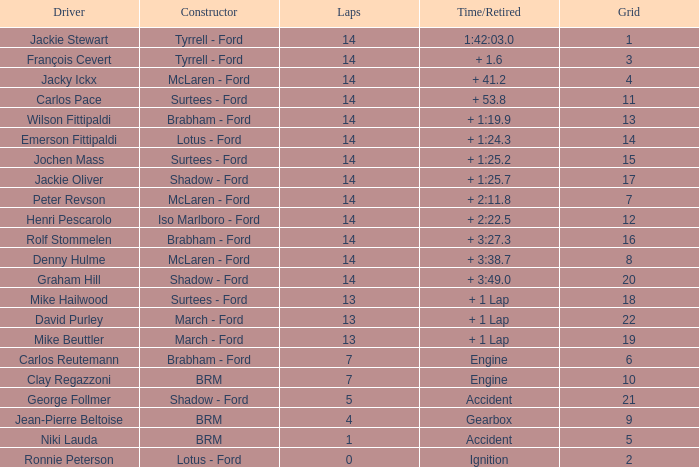What graduate has a time/retired of + 1:2 14.0. 